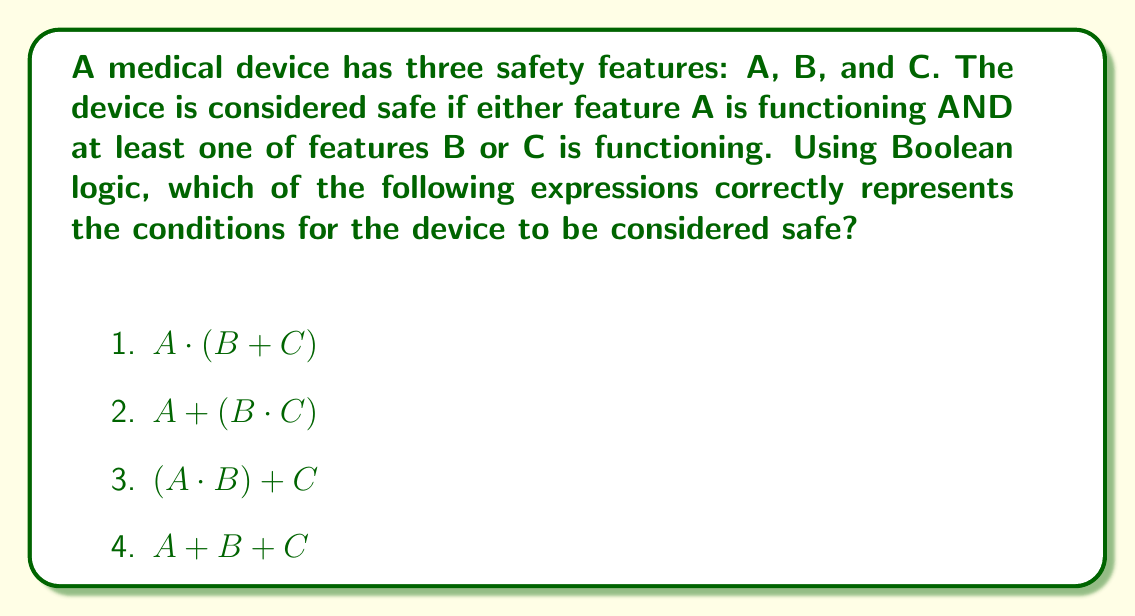Provide a solution to this math problem. Let's approach this step-by-step using Boolean algebra:

1) First, we need to translate the given conditions into Boolean logic:
   - Feature A must be functioning: This is represented by A
   - At least one of features B or C must be functioning: This is represented by $(B + C)$
   - Both conditions must be true: This is represented by the AND operation $(\cdot)$

2) Combining these conditions, we get: $A \cdot (B + C)$

3) Let's evaluate each option:
   
   1) $A \cdot (B + C)$: This correctly represents the given conditions.
   
   2) $A + (B \cdot C)$: This would mean the device is safe if A is functioning OR both B and C are functioning, which is not correct.
   
   3) $(A \cdot B) + C$: This would mean the device is safe if A and B are both functioning OR if C is functioning, which is not correct.
   
   4) $A + B + C$: This would mean the device is safe if any one of A, B, or C is functioning, which is not correct.

4) Therefore, the correct expression is $A \cdot (B + C)$, which corresponds to option 1.

This Boolean expression ensures that feature A must be functioning (represented by A) AND at least one of features B or C must be functioning (represented by $(B + C)$), exactly matching the safety requirements described in the question.
Answer: 1) $A \cdot (B + C)$ 